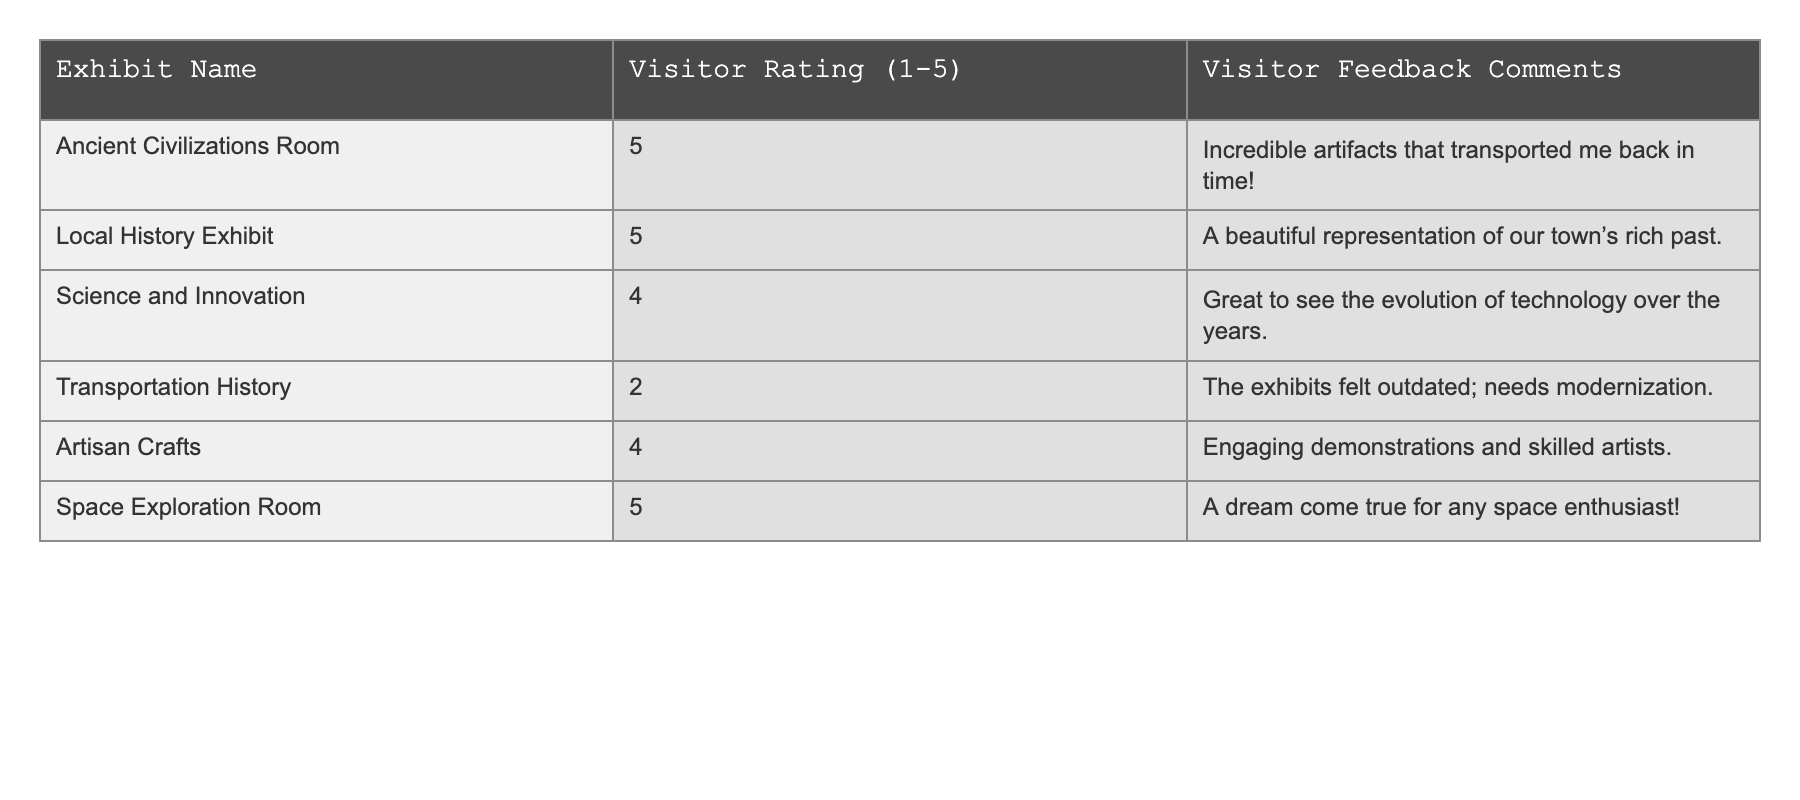What is the highest visitor rating among the exhibits? The table indicates that the highest rating is 5, which is given to multiple exhibits: "Ancient Civilizations Room," "Local History Exhibit," "Space Exploration Room."
Answer: 5 Which exhibit received the lowest rating? The lowest rating in the table is a 2, given to the "Transportation History" exhibit.
Answer: Transportation History How many exhibits received a rating of 4 or higher? The table shows 4 exhibits with ratings of 4 or higher: "Ancient Civilizations Room," "Local History Exhibit," "Space Exploration Room," and "Artisan Crafts."
Answer: 4 What is the average visitor rating of all exhibits? To find the average, sum the ratings: 5 + 5 + 4 + 2 + 4 + 5 = 25, then divide by the number of exhibits which is 6. Thus, the average is 25/6 ≈ 4.17.
Answer: 4.17 Did any exhibit receive a rating of 3? No exhibit in the table has a rating of 3; the ratings are either 2, 4, or 5.
Answer: No What is the difference in rating between the highest and lowest rated exhibits? The highest rating is 5 and the lowest is 2. The difference is 5 - 2 = 3.
Answer: 3 Which exhibit has the visitor feedback comment mentioning "outdated"? The "Transportation History" exhibit received the comment mentioning "outdated."
Answer: Transportation History Is there any exhibit rated below 4? Yes, the "Transportation History" exhibit is the only one with a rating below 4.
Answer: Yes What visitor feedback was provided for the "Space Exploration Room"? The feedback for the "Space Exploration Room" states, "A dream come true for any space enthusiast!"
Answer: "A dream come true for any space enthusiast!" Which exhibit received comments about engaging demonstrations? The "Artisan Crafts" exhibit received comments about engaging demonstrations.
Answer: Artisan Crafts 